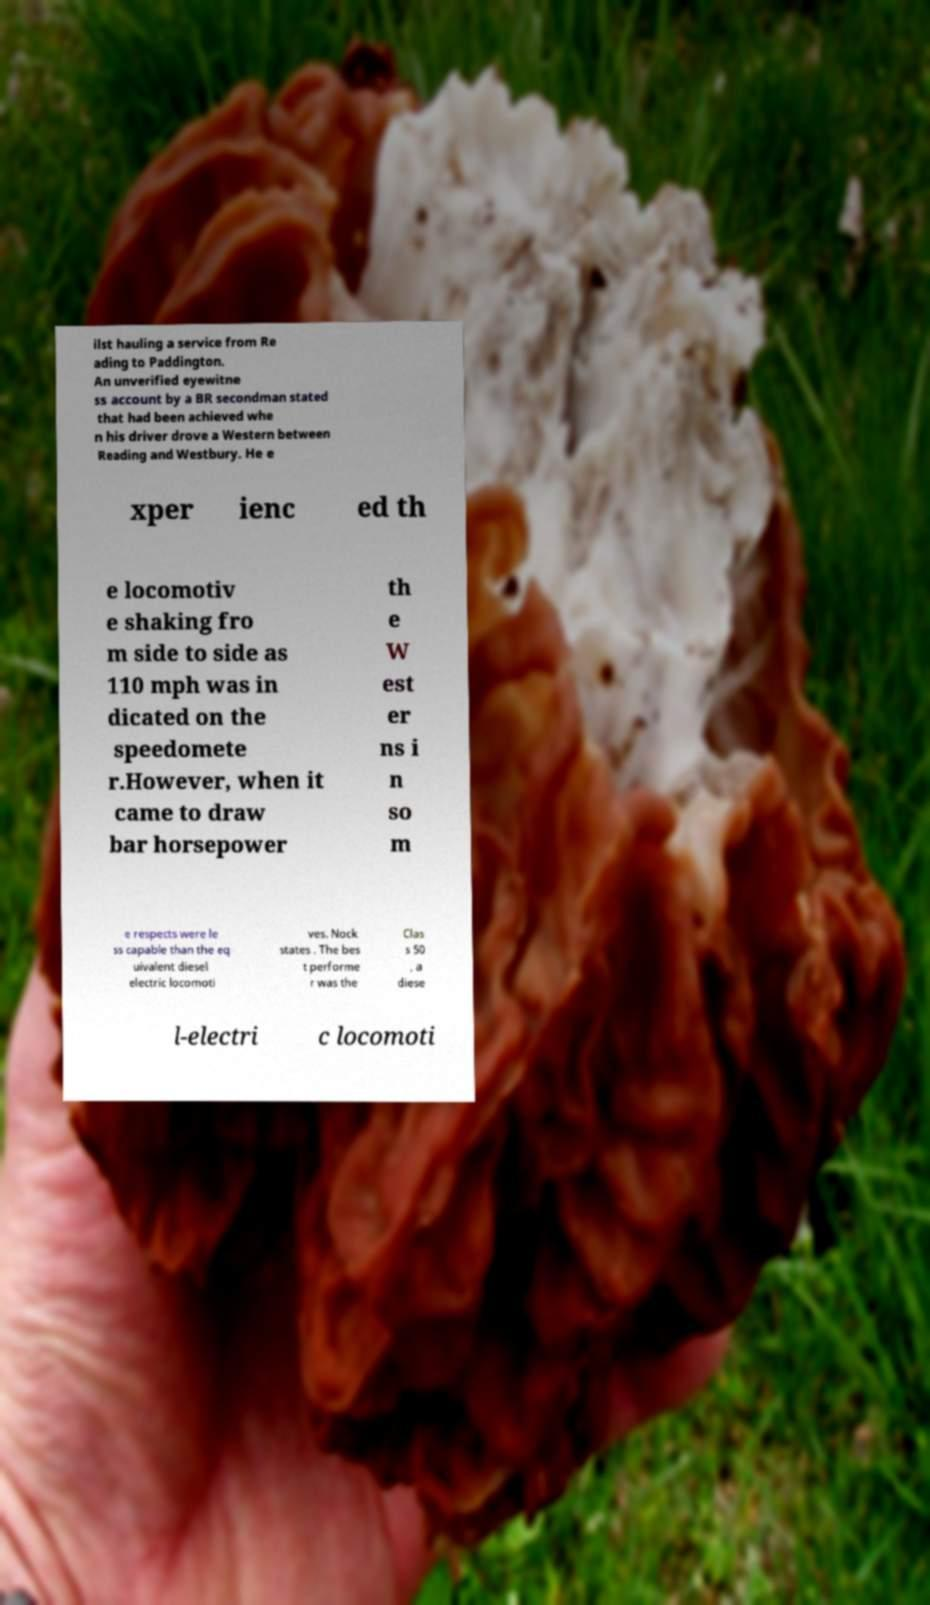What messages or text are displayed in this image? I need them in a readable, typed format. ilst hauling a service from Re ading to Paddington. An unverified eyewitne ss account by a BR secondman stated that had been achieved whe n his driver drove a Western between Reading and Westbury. He e xper ienc ed th e locomotiv e shaking fro m side to side as 110 mph was in dicated on the speedomete r.However, when it came to draw bar horsepower th e W est er ns i n so m e respects were le ss capable than the eq uivalent diesel electric locomoti ves. Nock states . The bes t performe r was the Clas s 50 , a diese l-electri c locomoti 